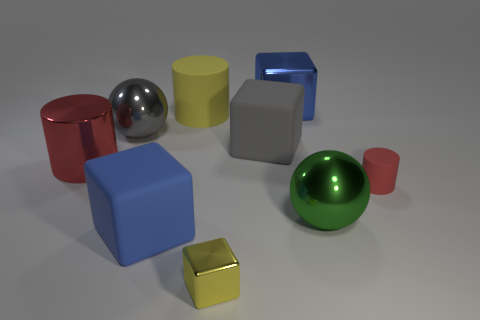Is the shape of the blue metallic thing the same as the tiny yellow thing?
Make the answer very short. Yes. There is a large gray metallic thing behind the red rubber cylinder in front of the yellow matte cylinder; what is its shape?
Keep it short and to the point. Sphere. Are there any big brown balls?
Ensure brevity in your answer.  No. How many yellow cubes are in front of the large sphere that is left of the big blue object that is behind the tiny cylinder?
Your answer should be compact. 1. Do the small metal thing and the blue thing in front of the tiny cylinder have the same shape?
Provide a short and direct response. Yes. Are there more large metal things than blue cubes?
Your answer should be compact. Yes. Do the yellow thing in front of the large red metal cylinder and the small red thing have the same shape?
Offer a very short reply. No. Is the number of blocks left of the gray metallic object greater than the number of small purple rubber cylinders?
Offer a terse response. No. There is a metal object behind the yellow thing that is behind the tiny matte thing; what is its color?
Offer a terse response. Blue. What number of tiny blue metal balls are there?
Your answer should be very brief. 0. 